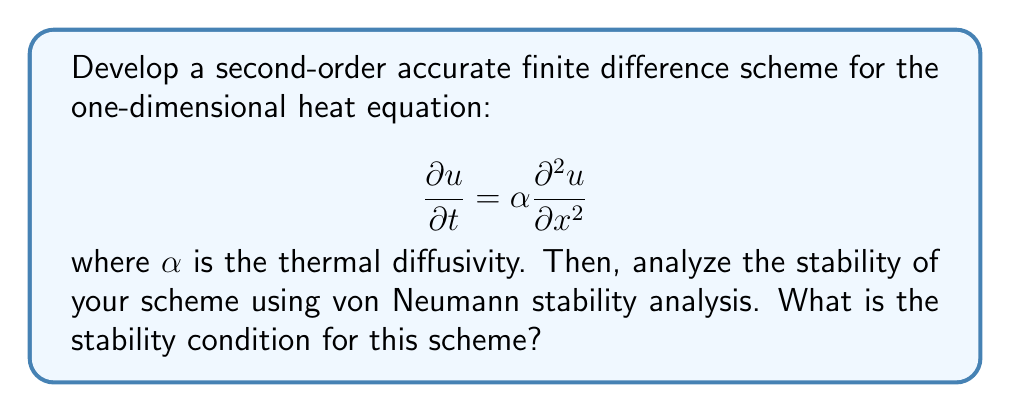Provide a solution to this math problem. Let's approach this step-by-step:

1) First, we need to discretize the equation using finite differences. We'll use central difference for the spatial derivative and forward difference for the time derivative.

   Let $u_j^n$ represent the solution at spatial point $j$ and time step $n$.

   $$\frac{\partial u}{\partial t} \approx \frac{u_j^{n+1} - u_j^n}{\Delta t}$$
   
   $$\frac{\partial^2 u}{\partial x^2} \approx \frac{u_{j+1}^n - 2u_j^n + u_{j-1}^n}{(\Delta x)^2}$$

2) Substituting these into the original equation:

   $$\frac{u_j^{n+1} - u_j^n}{\Delta t} = \alpha \frac{u_{j+1}^n - 2u_j^n + u_{j-1}^n}{(\Delta x)^2}$$

3) Rearranging to solve for $u_j^{n+1}$:

   $$u_j^{n+1} = u_j^n + \frac{\alpha \Delta t}{(\Delta x)^2}(u_{j+1}^n - 2u_j^n + u_{j-1}^n)$$

   This is our finite difference scheme.

4) Now, let's analyze the stability using von Neumann analysis. We assume a solution of the form:

   $$u_j^n = \xi^n e^{ikj\Delta x}$$

   where $i$ is the imaginary unit, $k$ is the wave number, and $\xi$ is the amplification factor.

5) Substituting this into our scheme:

   $$\xi^{n+1} e^{ikj\Delta x} = \xi^n e^{ikj\Delta x} + \frac{\alpha \Delta t}{(\Delta x)^2}(\xi^n e^{ik(j+1)\Delta x} - 2\xi^n e^{ikj\Delta x} + \xi^n e^{ik(j-1)\Delta x})$$

6) Simplifying:

   $$\xi = 1 + \frac{\alpha \Delta t}{(\Delta x)^2}(e^{ik\Delta x} - 2 + e^{-ik\Delta x})$$

   $$\xi = 1 + \frac{\alpha \Delta t}{(\Delta x)^2}(2\cos(k\Delta x) - 2)$$

   $$\xi = 1 - 4\frac{\alpha \Delta t}{(\Delta x)^2}\sin^2(\frac{k\Delta x}{2})$$

7) For stability, we need $|\xi| \leq 1$ for all $k$. The maximum value of $\sin^2(\frac{k\Delta x}{2})$ is 1, so:

   $$-1 \leq 1 - 4\frac{\alpha \Delta t}{(\Delta x)^2} \leq 1$$

8) This gives us the stability condition:

   $$\frac{\alpha \Delta t}{(\Delta x)^2} \leq \frac{1}{2}$$
Answer: The stability condition for the second-order accurate finite difference scheme for the one-dimensional heat equation is:

$$\frac{\alpha \Delta t}{(\Delta x)^2} \leq \frac{1}{2}$$

where $\alpha$ is the thermal diffusivity, $\Delta t$ is the time step, and $\Delta x$ is the spatial step. 